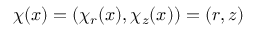Convert formula to latex. <formula><loc_0><loc_0><loc_500><loc_500>\chi ( x ) = ( \chi _ { r } ( x ) , \chi _ { z } ( x ) ) = ( r , z )</formula> 